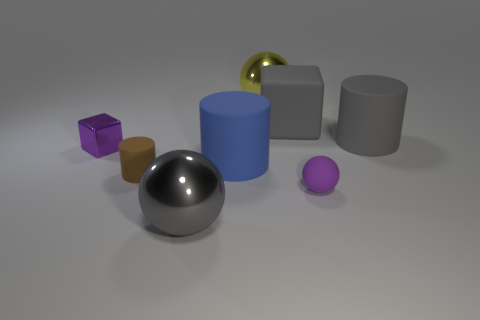Subtract 1 cylinders. How many cylinders are left? 2 Subtract all shiny balls. How many balls are left? 1 Add 1 brown things. How many objects exist? 9 Subtract all cylinders. How many objects are left? 5 Add 1 gray cylinders. How many gray cylinders are left? 2 Add 8 tiny brown matte balls. How many tiny brown matte balls exist? 8 Subtract 0 green balls. How many objects are left? 8 Subtract all big gray objects. Subtract all small cylinders. How many objects are left? 4 